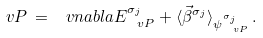<formula> <loc_0><loc_0><loc_500><loc_500>\ v P \, = \, \ v n a b l a E _ { \ v P } ^ { \sigma _ { j } } + \langle \vec { \beta } ^ { \sigma _ { j } } \rangle _ { \psi _ { \ v P } ^ { \sigma _ { j } } } \, .</formula> 